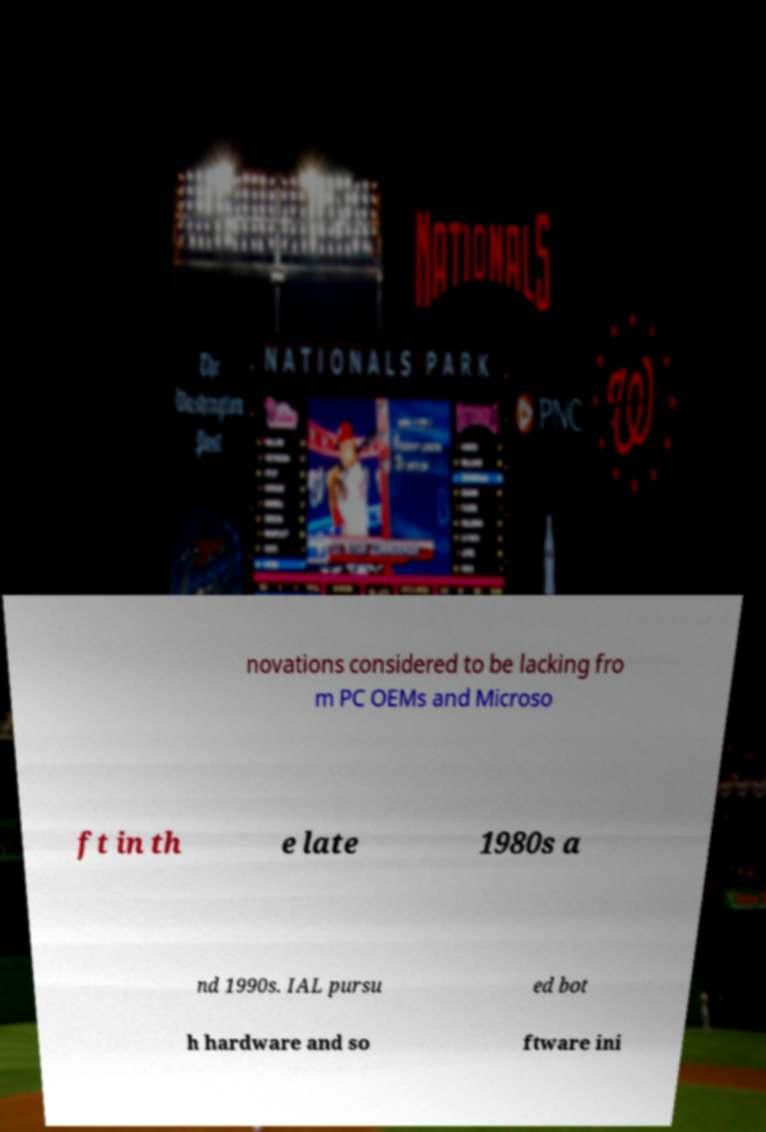Can you accurately transcribe the text from the provided image for me? novations considered to be lacking fro m PC OEMs and Microso ft in th e late 1980s a nd 1990s. IAL pursu ed bot h hardware and so ftware ini 